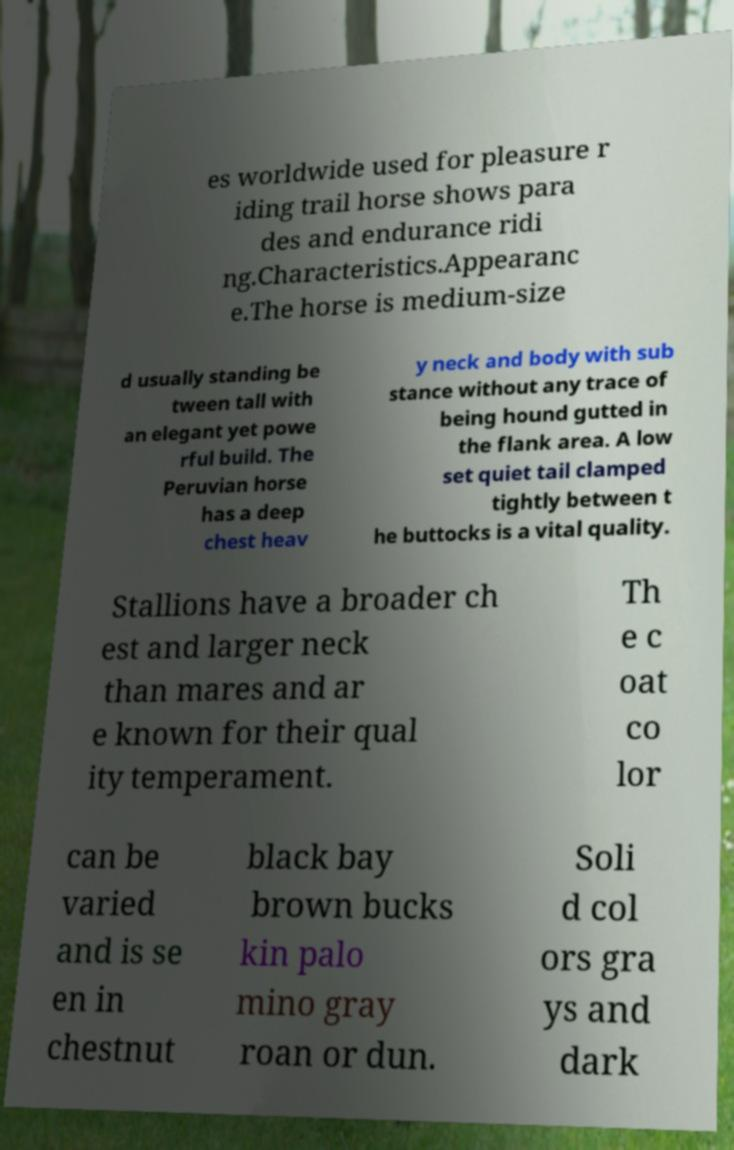Please identify and transcribe the text found in this image. es worldwide used for pleasure r iding trail horse shows para des and endurance ridi ng.Characteristics.Appearanc e.The horse is medium-size d usually standing be tween tall with an elegant yet powe rful build. The Peruvian horse has a deep chest heav y neck and body with sub stance without any trace of being hound gutted in the flank area. A low set quiet tail clamped tightly between t he buttocks is a vital quality. Stallions have a broader ch est and larger neck than mares and ar e known for their qual ity temperament. Th e c oat co lor can be varied and is se en in chestnut black bay brown bucks kin palo mino gray roan or dun. Soli d col ors gra ys and dark 